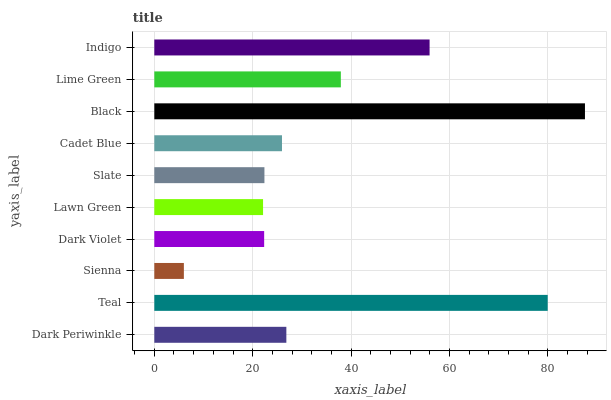Is Sienna the minimum?
Answer yes or no. Yes. Is Black the maximum?
Answer yes or no. Yes. Is Teal the minimum?
Answer yes or no. No. Is Teal the maximum?
Answer yes or no. No. Is Teal greater than Dark Periwinkle?
Answer yes or no. Yes. Is Dark Periwinkle less than Teal?
Answer yes or no. Yes. Is Dark Periwinkle greater than Teal?
Answer yes or no. No. Is Teal less than Dark Periwinkle?
Answer yes or no. No. Is Dark Periwinkle the high median?
Answer yes or no. Yes. Is Cadet Blue the low median?
Answer yes or no. Yes. Is Slate the high median?
Answer yes or no. No. Is Black the low median?
Answer yes or no. No. 